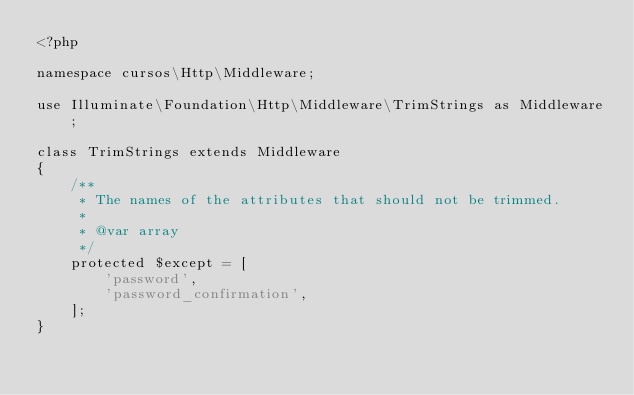<code> <loc_0><loc_0><loc_500><loc_500><_PHP_><?php

namespace cursos\Http\Middleware;

use Illuminate\Foundation\Http\Middleware\TrimStrings as Middleware;

class TrimStrings extends Middleware
{
    /**
     * The names of the attributes that should not be trimmed.
     *
     * @var array
     */
    protected $except = [
        'password',
        'password_confirmation',
    ];
}
</code> 